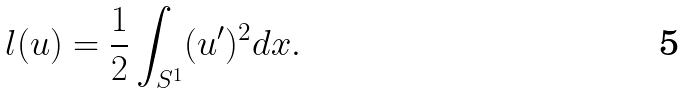<formula> <loc_0><loc_0><loc_500><loc_500>l ( u ) = \frac { 1 } { 2 } \int _ { S ^ { 1 } } ( u ^ { \prime } ) ^ { 2 } d x .</formula> 